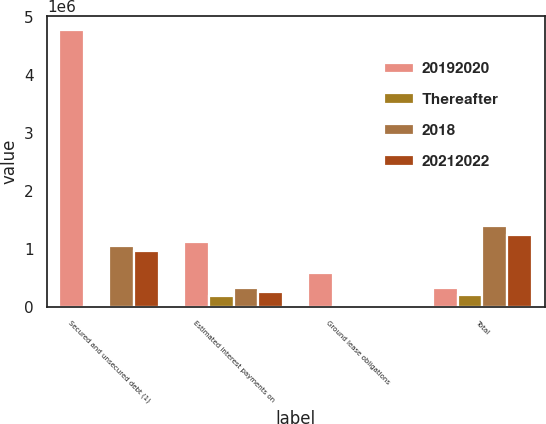<chart> <loc_0><loc_0><loc_500><loc_500><stacked_bar_chart><ecel><fcel>Secured and unsecured debt (1)<fcel>Estimated interest payments on<fcel>Ground lease obligations<fcel>Total<nl><fcel>20192020<fcel>4.77954e+06<fcel>1.12269e+06<fcel>580012<fcel>318752<nl><fcel>Thereafter<fcel>7291<fcel>177315<fcel>12098<fcel>199283<nl><fcel>2018<fcel>1.04468e+06<fcel>318752<fcel>24333<fcel>1.38987e+06<nl><fcel>20212022<fcel>964151<fcel>259769<fcel>23376<fcel>1.24757e+06<nl></chart> 